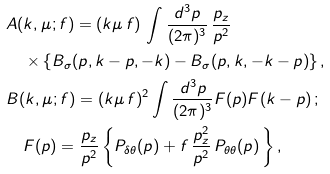Convert formula to latex. <formula><loc_0><loc_0><loc_500><loc_500>& A ( k , \mu ; f ) = ( k \mu \, f ) \, \int \frac { d ^ { 3 } p } { ( 2 \pi ) ^ { 3 } } \, \frac { p _ { z } } { p ^ { 2 } } \\ & \quad \times \left \{ B _ { \sigma } ( p , k - p , - k ) - B _ { \sigma } ( p , k , - k - p ) \right \} , \\ & B ( k , \mu ; f ) = ( k \mu \, f ) ^ { 2 } \int \frac { d ^ { 3 } p } { ( 2 \pi ) ^ { 3 } } F ( p ) F ( k - p ) \, ; \\ & \quad F ( p ) = \frac { p _ { z } } { p ^ { 2 } } \left \{ P _ { \delta \theta } ( p ) + f \, \frac { p _ { z } ^ { 2 } } { p ^ { 2 } } \, P _ { \theta \theta } ( p ) \, \right \} ,</formula> 